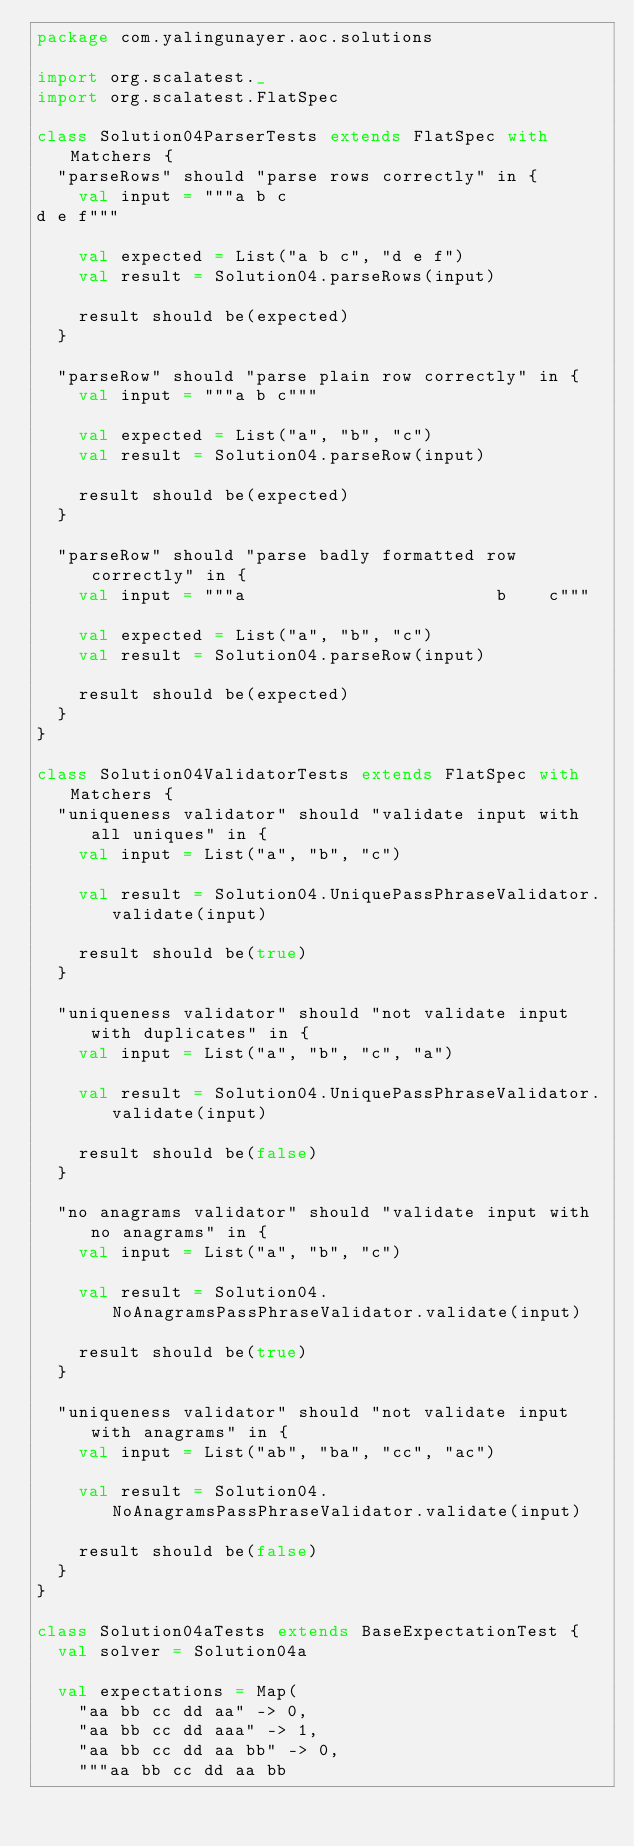<code> <loc_0><loc_0><loc_500><loc_500><_Scala_>package com.yalingunayer.aoc.solutions

import org.scalatest._
import org.scalatest.FlatSpec

class Solution04ParserTests extends FlatSpec with Matchers {
  "parseRows" should "parse rows correctly" in {
    val input = """a b c
d e f"""

    val expected = List("a b c", "d e f")
    val result = Solution04.parseRows(input)

    result should be(expected)
  }

  "parseRow" should "parse plain row correctly" in {
    val input = """a b c"""

    val expected = List("a", "b", "c")
    val result = Solution04.parseRow(input)

    result should be(expected)
  }

  "parseRow" should "parse badly formatted row correctly" in {
    val input = """a                        b    c"""

    val expected = List("a", "b", "c")
    val result = Solution04.parseRow(input)

    result should be(expected)
  }
}

class Solution04ValidatorTests extends FlatSpec with Matchers {
  "uniqueness validator" should "validate input with all uniques" in {
    val input = List("a", "b", "c")

    val result = Solution04.UniquePassPhraseValidator.validate(input)

    result should be(true)
  }

  "uniqueness validator" should "not validate input with duplicates" in {
    val input = List("a", "b", "c", "a")

    val result = Solution04.UniquePassPhraseValidator.validate(input)

    result should be(false)
  }

  "no anagrams validator" should "validate input with no anagrams" in {
    val input = List("a", "b", "c")

    val result = Solution04.NoAnagramsPassPhraseValidator.validate(input)

    result should be(true)
  }

  "uniqueness validator" should "not validate input with anagrams" in {
    val input = List("ab", "ba", "cc", "ac")

    val result = Solution04.NoAnagramsPassPhraseValidator.validate(input)

    result should be(false)
  }
}

class Solution04aTests extends BaseExpectationTest {
  val solver = Solution04a

  val expectations = Map(
    "aa bb cc dd aa" -> 0,
    "aa bb cc dd aaa" -> 1,
    "aa bb cc dd aa bb" -> 0,
    """aa bb cc dd aa bb</code> 